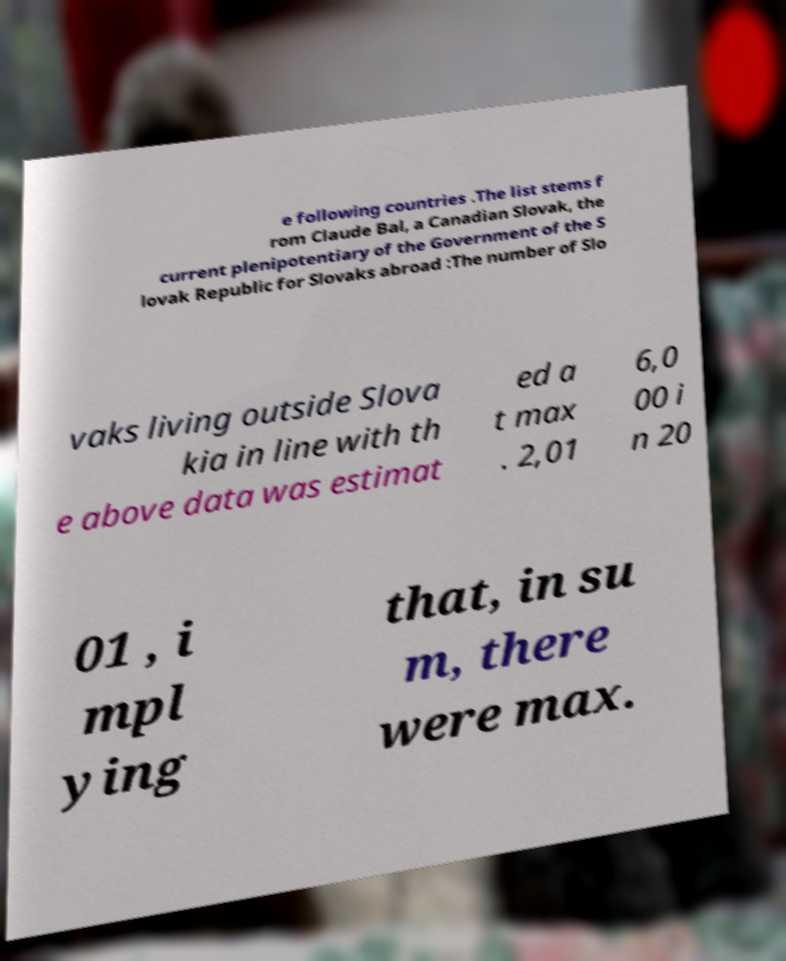There's text embedded in this image that I need extracted. Can you transcribe it verbatim? e following countries .The list stems f rom Claude Bal, a Canadian Slovak, the current plenipotentiary of the Government of the S lovak Republic for Slovaks abroad :The number of Slo vaks living outside Slova kia in line with th e above data was estimat ed a t max . 2,01 6,0 00 i n 20 01 , i mpl ying that, in su m, there were max. 